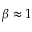<formula> <loc_0><loc_0><loc_500><loc_500>\beta \approx 1</formula> 